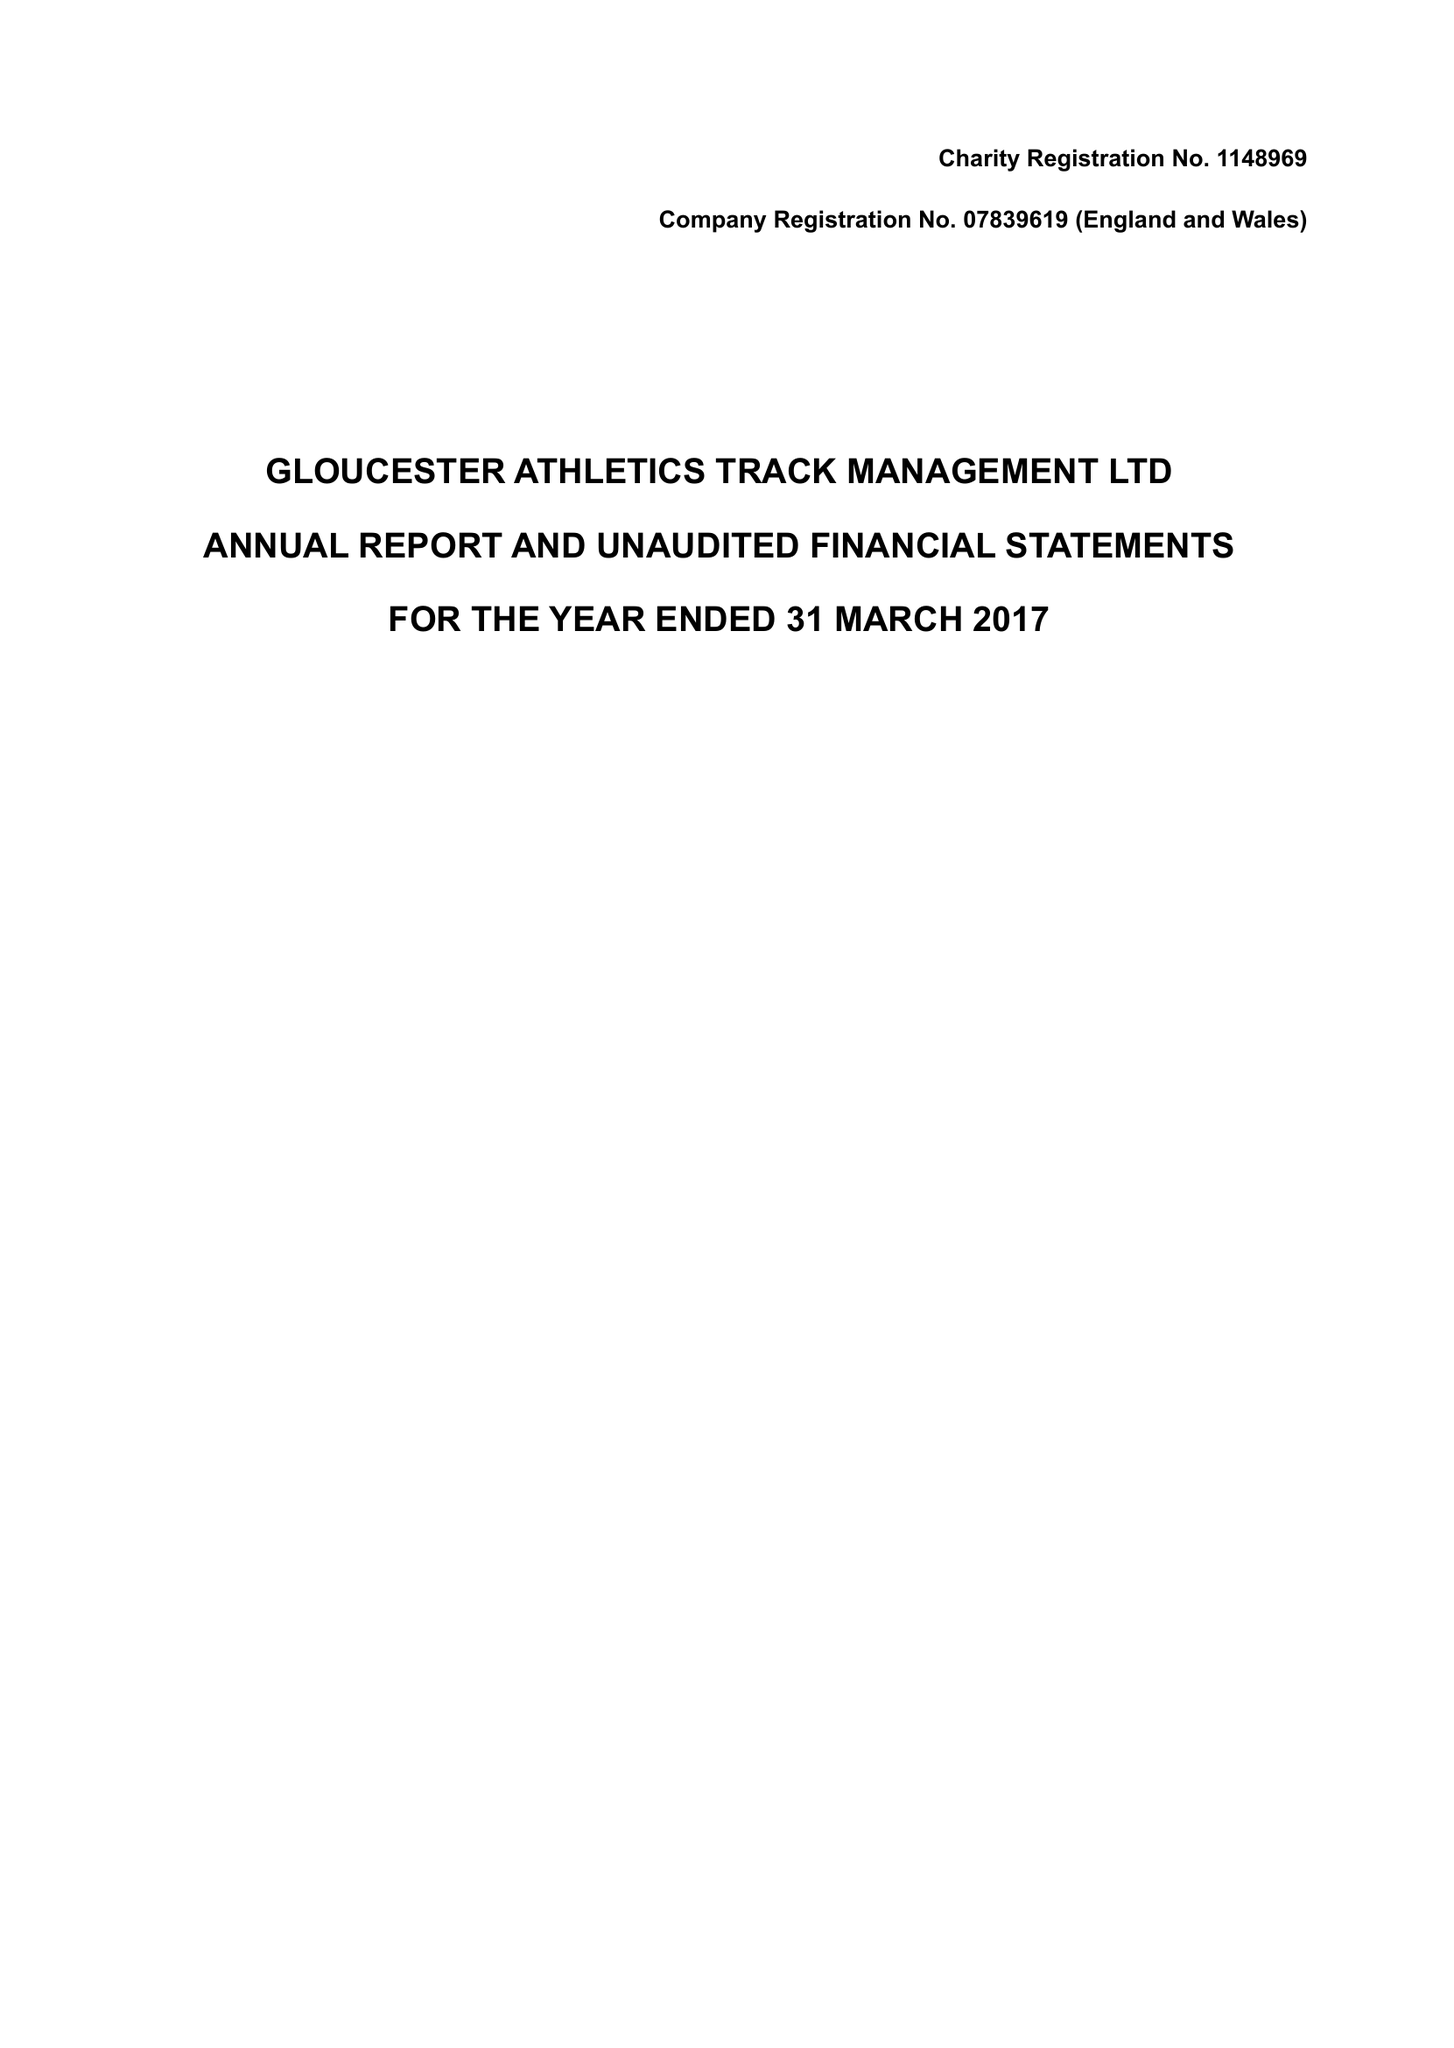What is the value for the spending_annually_in_british_pounds?
Answer the question using a single word or phrase. 18364.00 